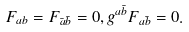Convert formula to latex. <formula><loc_0><loc_0><loc_500><loc_500>F _ { a b } = F _ { \bar { a } \bar { b } } = 0 , g ^ { a \bar { b } } F _ { a \bar { b } } = 0 .</formula> 